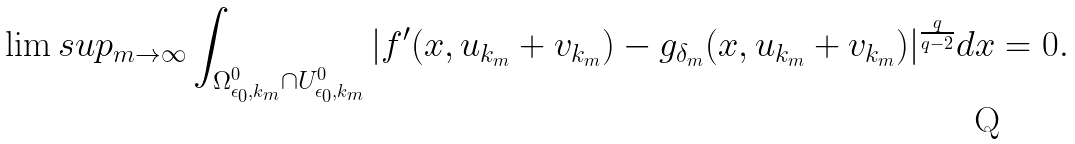Convert formula to latex. <formula><loc_0><loc_0><loc_500><loc_500>\lim s u p _ { m \rightarrow \infty } \int _ { \Omega ^ { 0 } _ { \epsilon _ { 0 } , k _ { m } } \cap U ^ { 0 } _ { \epsilon _ { 0 } , k _ { m } } } | f ^ { \prime } ( x , u _ { k _ { m } } + v _ { k _ { m } } ) - g _ { \delta _ { m } } ( x , u _ { k _ { m } } + v _ { k _ { m } } ) | ^ { \frac { q } { q - 2 } } d x = 0 .</formula> 